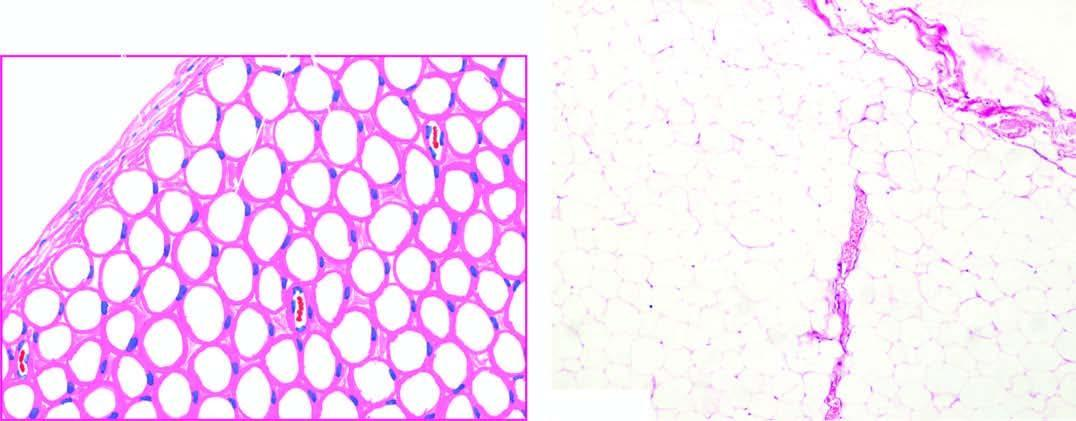does the tumour show a thin capsule and underlying lobules of mature adipose cells separated by delicate fibrous septa?
Answer the question using a single word or phrase. Yes 